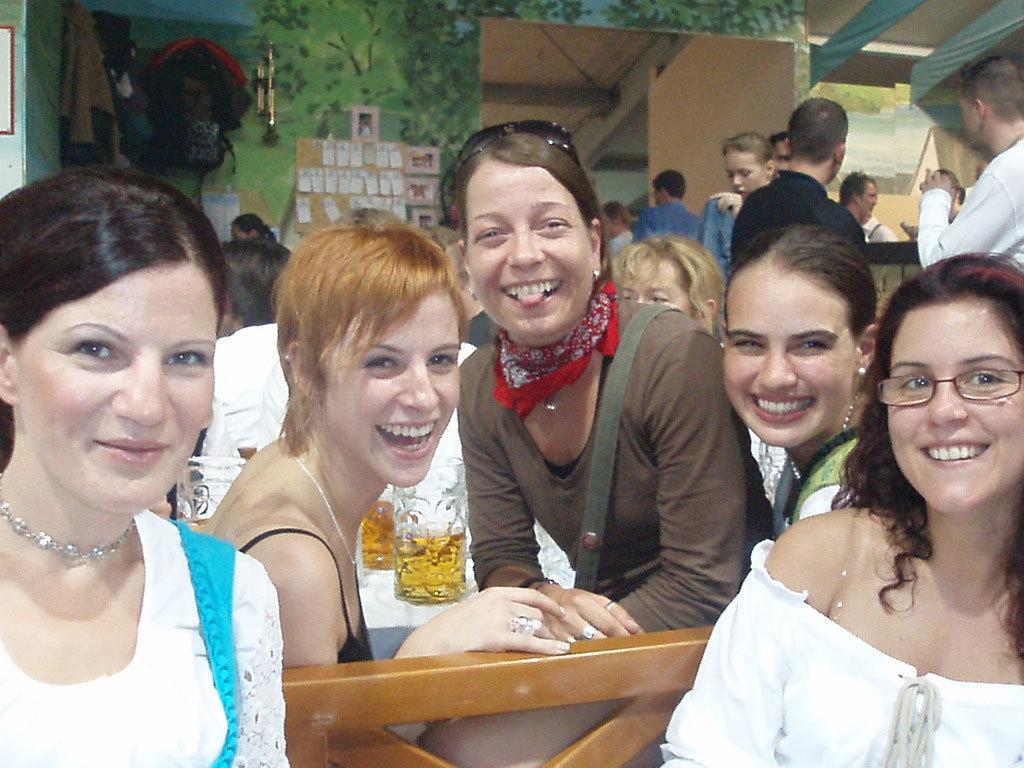Could you give a brief overview of what you see in this image? In the center of the image some persons are sitting. In the middle of the image there is a table. On the table we can see glasses which contains beer. On the right side of the image some persons are standing. In the background of the image we can see wall, boards, bag, clothes, photo frame. At the top right corner there is a roof. 